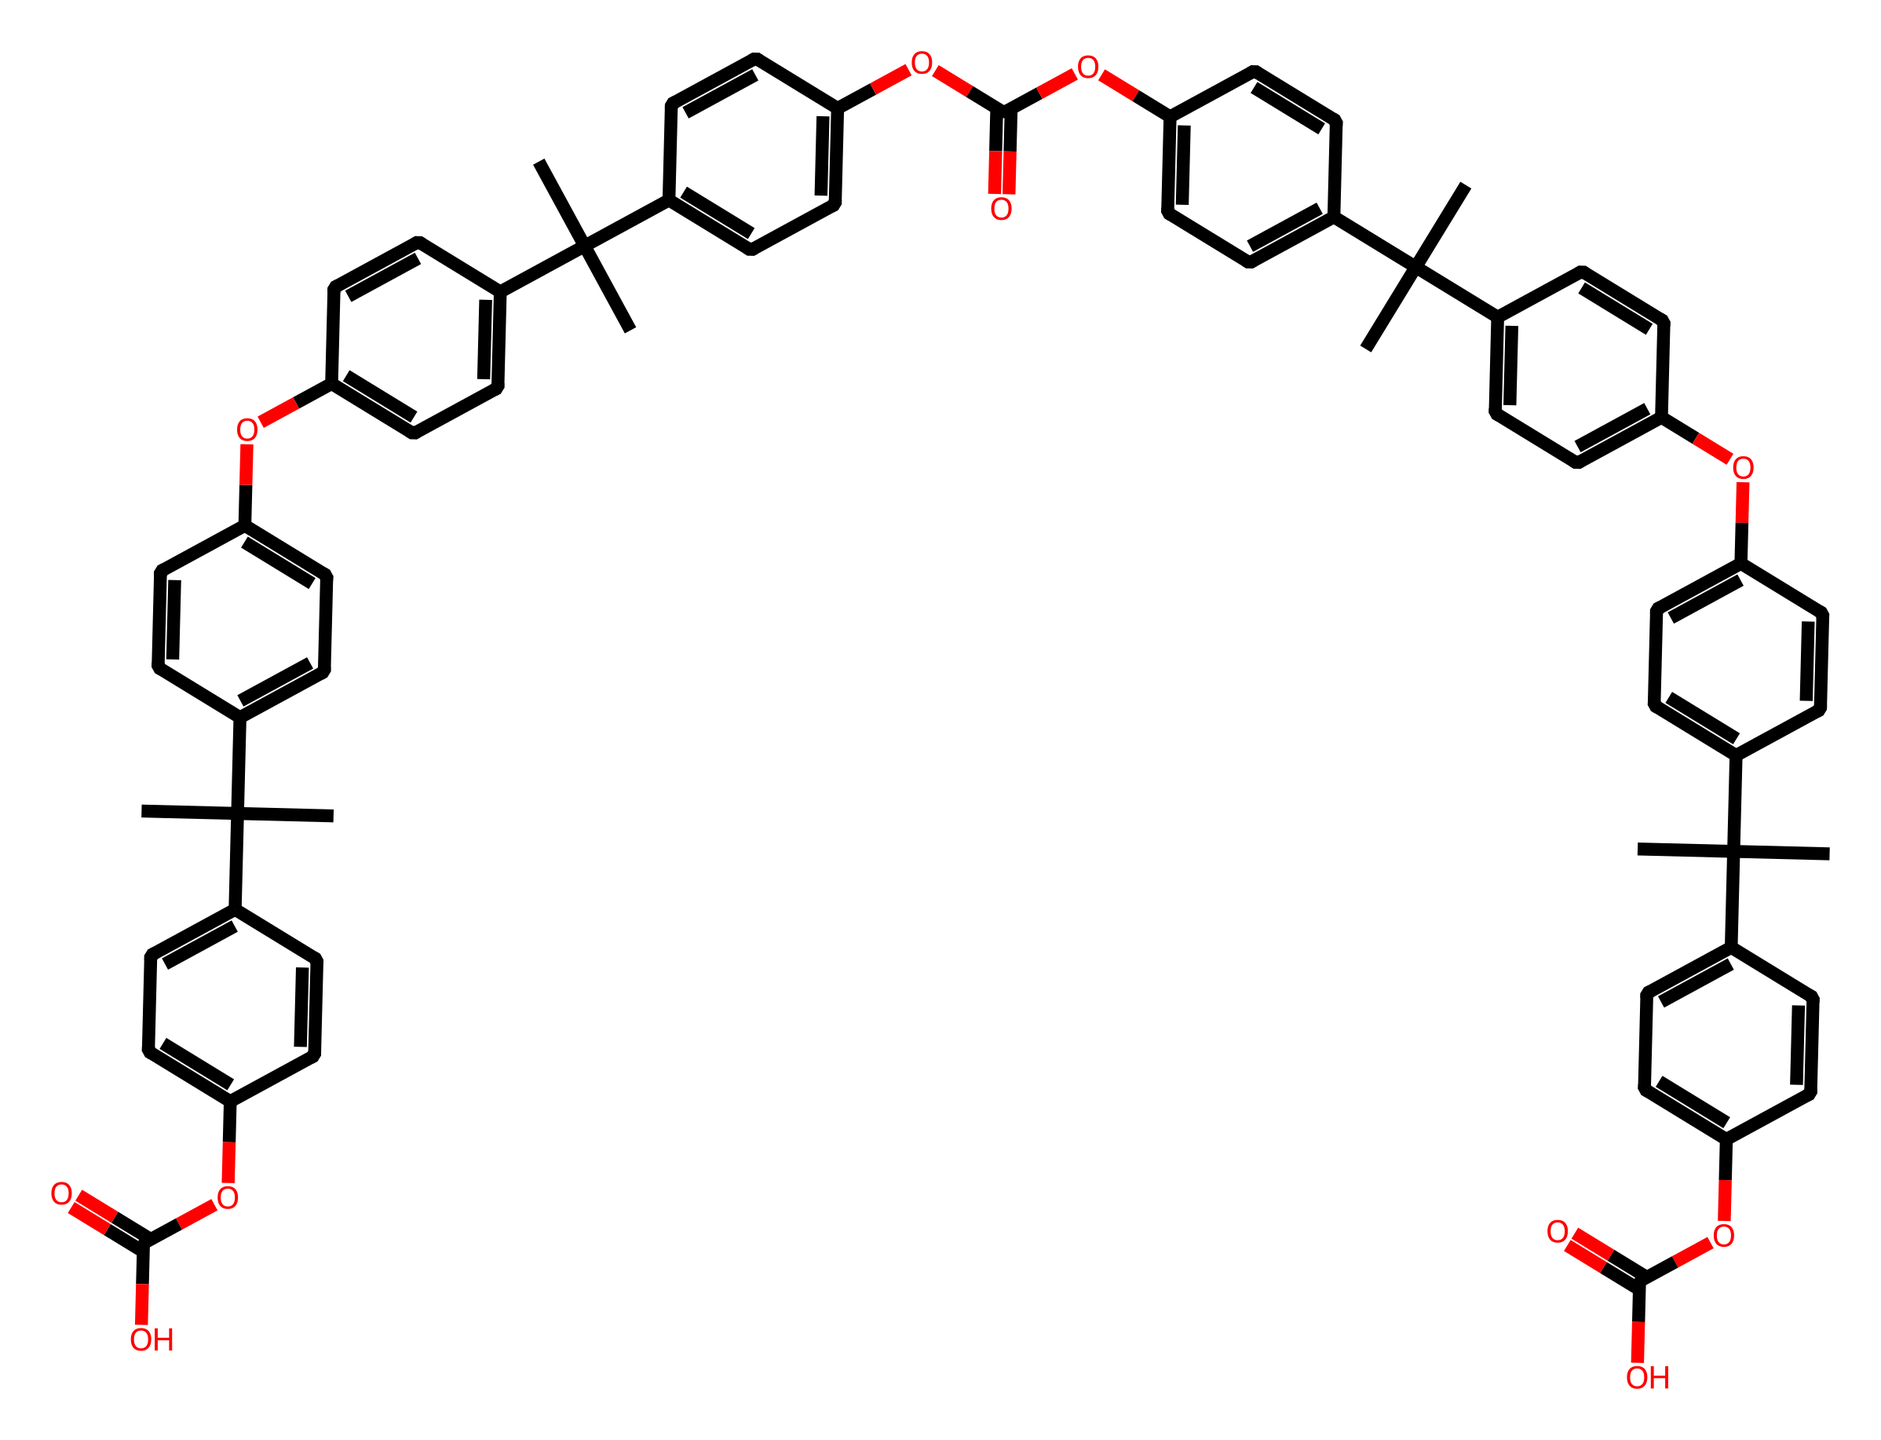What is the primary functional group present in the structure? The presence of an ester functional group can be identified by the -C(=O)O part of the structure. Scanning the structure, we see several instances of -OC(=O)O, confirming the components of the ester group.
Answer: ester How many aromatic rings are present in the chemical? By analyzing the structure, we can see multiple distinct rings that match the criteria for aromaticity, marked by alternating double bonds. Counting these carefully, we find there are six aromatic rings.
Answer: six What type of polymer is represented by this chemical structure? The presence of repeating units and functional groups indicative of polycarbonate characteristics suggests it is a type of thermoplastic polymer. Identifying the structure shows that it is indeed a polycarbonate.
Answer: polycarbonate What is the molecular formula based on the SMILES representation? Analyzing the SMILES representation, we can count the carbons, hydrogens, and other atoms to derive the complete molecular formula. Upon careful counting, the molecular formula is C40H46O12.
Answer: C40H46O12 What is the significance of the hydroxyl (-OH) groups in this chemical? Hydroxyl groups often enhance hydrogen bonding, affecting the solubility and physical properties of compounds. In the context of polycarbonate, they can play a role in providing clarity and strength in optical applications.
Answer: enhances properties How many carbon atoms are present in the structure? Counting the carbon atoms directly from the SMILES string or identifying them based on connectivity in the visual representation leads to a total of forty carbon atoms in this structure.
Answer: forty What is the importance of polycarbonate in camera lenses? Polycarbonate is favored in camera lenses due to its high impact resistance and optical clarity. Its properties suit the requirements for durability and lightweight characteristics in lens design.
Answer: impact resistance 